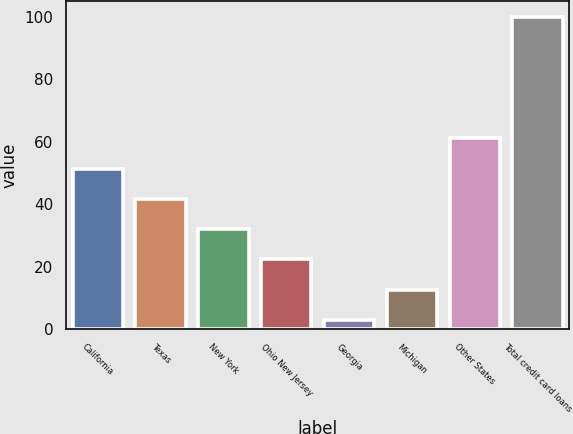Convert chart. <chart><loc_0><loc_0><loc_500><loc_500><bar_chart><fcel>California<fcel>Texas<fcel>New York<fcel>Ohio New Jersey<fcel>Georgia<fcel>Michigan<fcel>Other States<fcel>Total credit card loans<nl><fcel>51.45<fcel>41.74<fcel>32.03<fcel>22.32<fcel>2.9<fcel>12.61<fcel>61.16<fcel>100<nl></chart> 